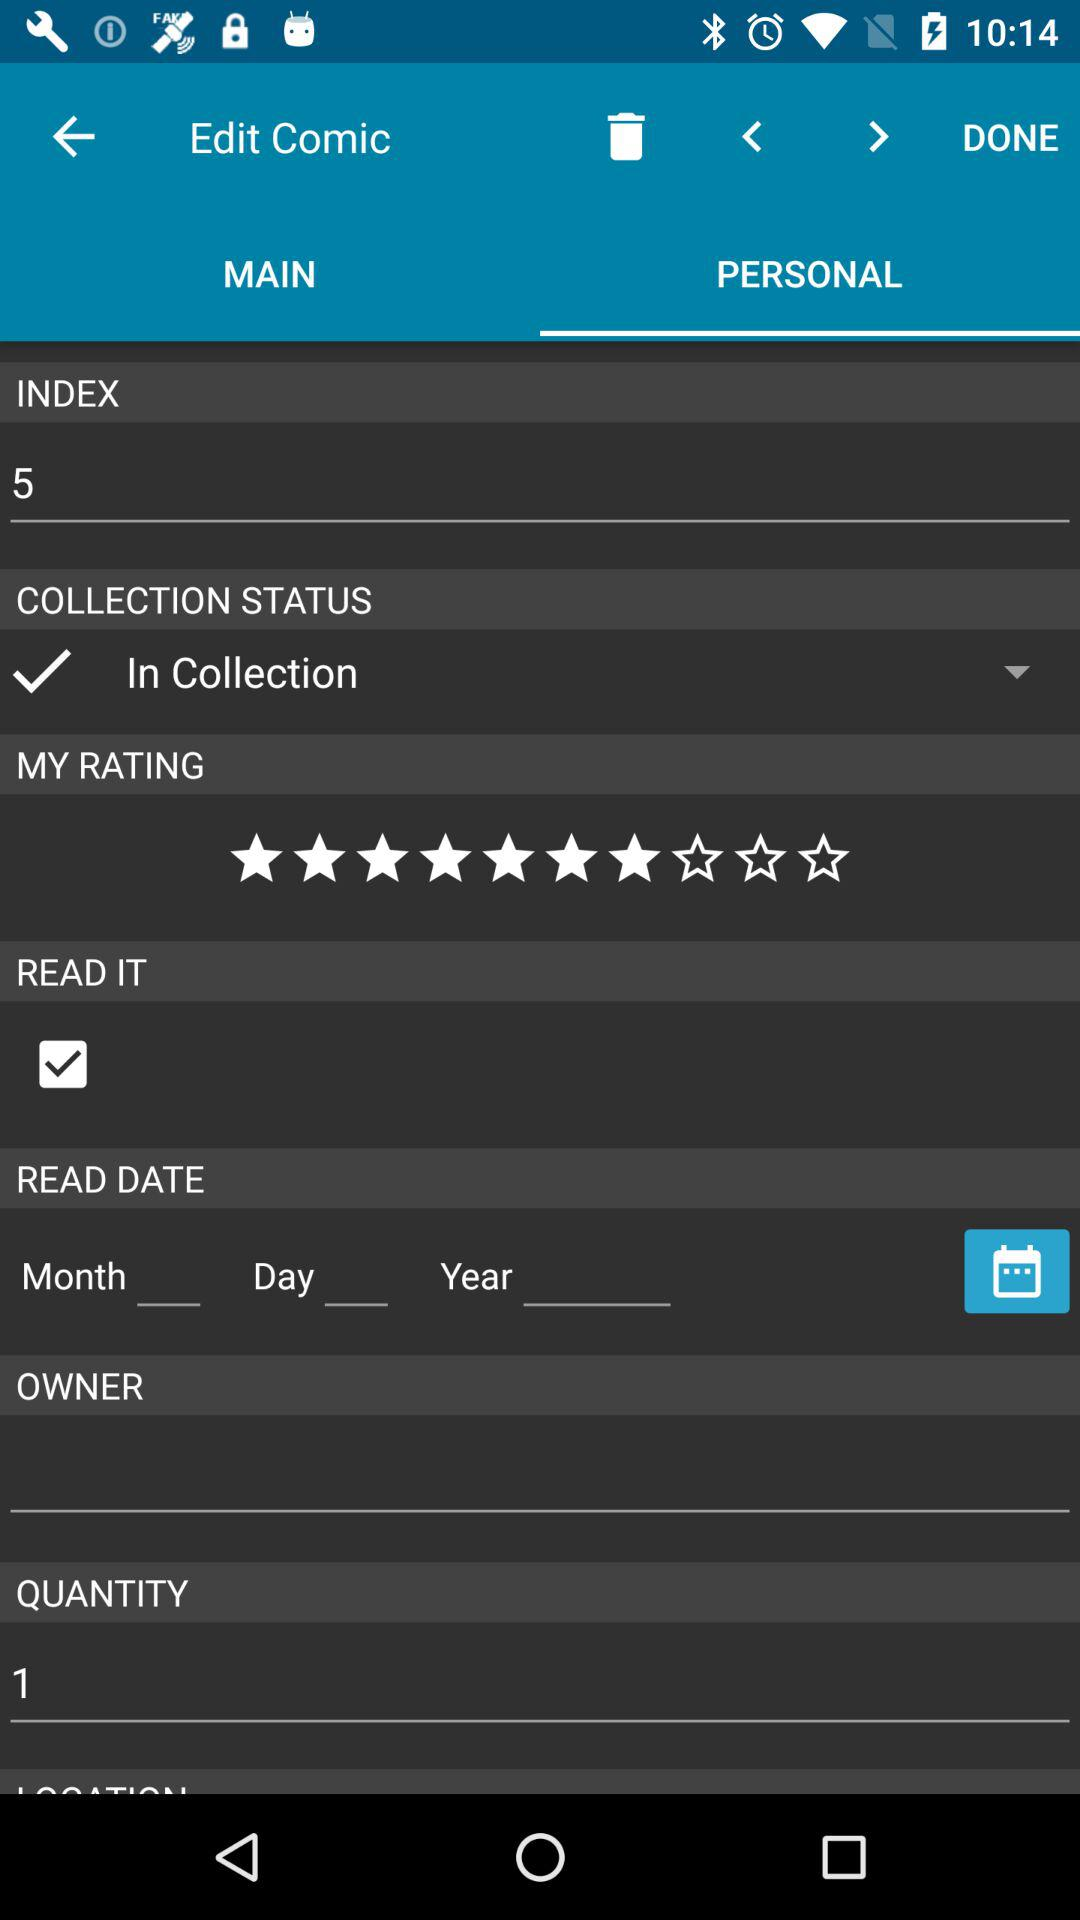What is the quantity of comics? The quantity is 1. 